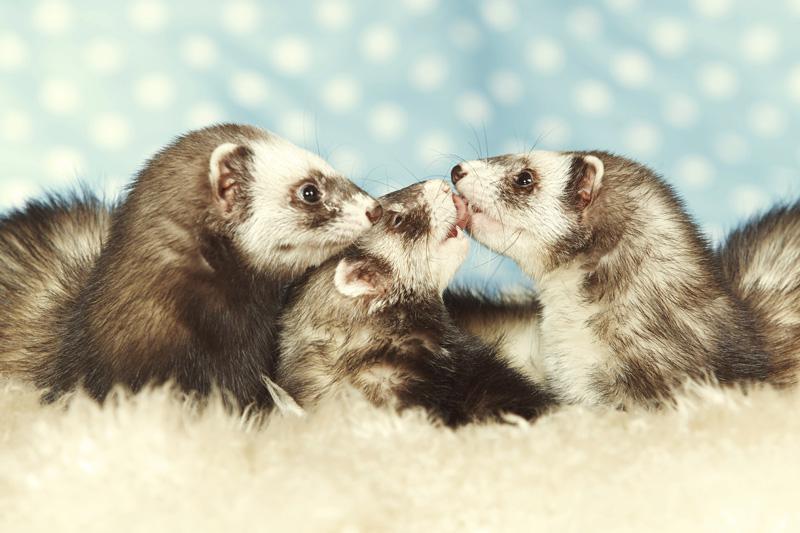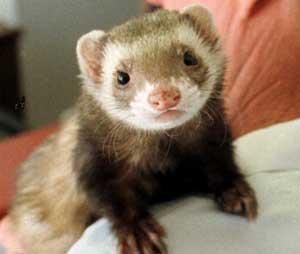The first image is the image on the left, the second image is the image on the right. Analyze the images presented: Is the assertion "There are three ferrets in one of the images." valid? Answer yes or no. Yes. The first image is the image on the left, the second image is the image on the right. Examine the images to the left and right. Is the description "There are at most 3 ferretts in the image pair." accurate? Answer yes or no. No. 